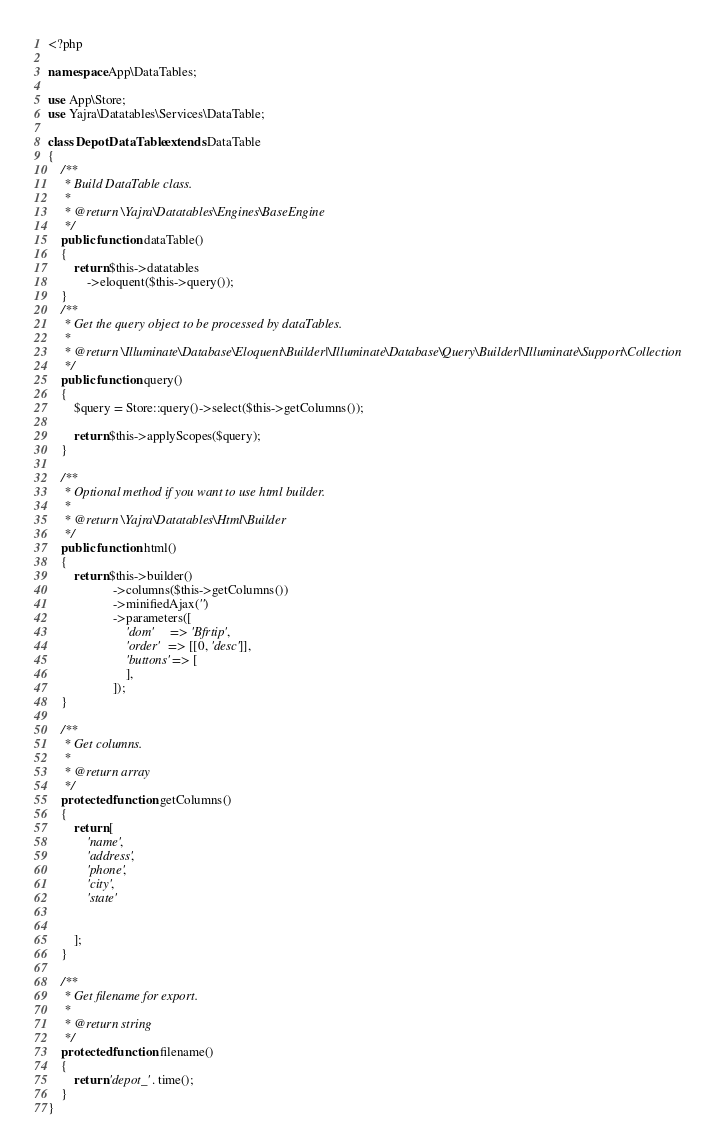Convert code to text. <code><loc_0><loc_0><loc_500><loc_500><_PHP_><?php

namespace App\DataTables;

use App\Store;
use Yajra\Datatables\Services\DataTable;

class DepotDataTable extends DataTable
{
    /**
     * Build DataTable class.
     *
     * @return \Yajra\Datatables\Engines\BaseEngine
     */
    public function dataTable()
    {
        return $this->datatables
            ->eloquent($this->query());
    }
    /**
     * Get the query object to be processed by dataTables.
     *
     * @return \Illuminate\Database\Eloquent\Builder|\Illuminate\Database\Query\Builder|\Illuminate\Support\Collection
     */
    public function query()
    {
        $query = Store::query()->select($this->getColumns());

        return $this->applyScopes($query);
    }

    /**
     * Optional method if you want to use html builder.
     *
     * @return \Yajra\Datatables\Html\Builder
     */
    public function html()
    {
        return $this->builder()
                    ->columns($this->getColumns())
                    ->minifiedAjax('')
                    ->parameters([
                        'dom'     => 'Bfrtip',
                        'order'   => [[0, 'desc']],
                        'buttons' => [
                        ],
                    ]);
    }

    /**
     * Get columns.
     *
     * @return array
     */
    protected function getColumns()
    {
        return [
            'name',
            'address',
            'phone',
            'city',
            'state'


        ];
    }

    /**
     * Get filename for export.
     *
     * @return string
     */
    protected function filename()
    {
        return 'depot_' . time();
    }
}
</code> 